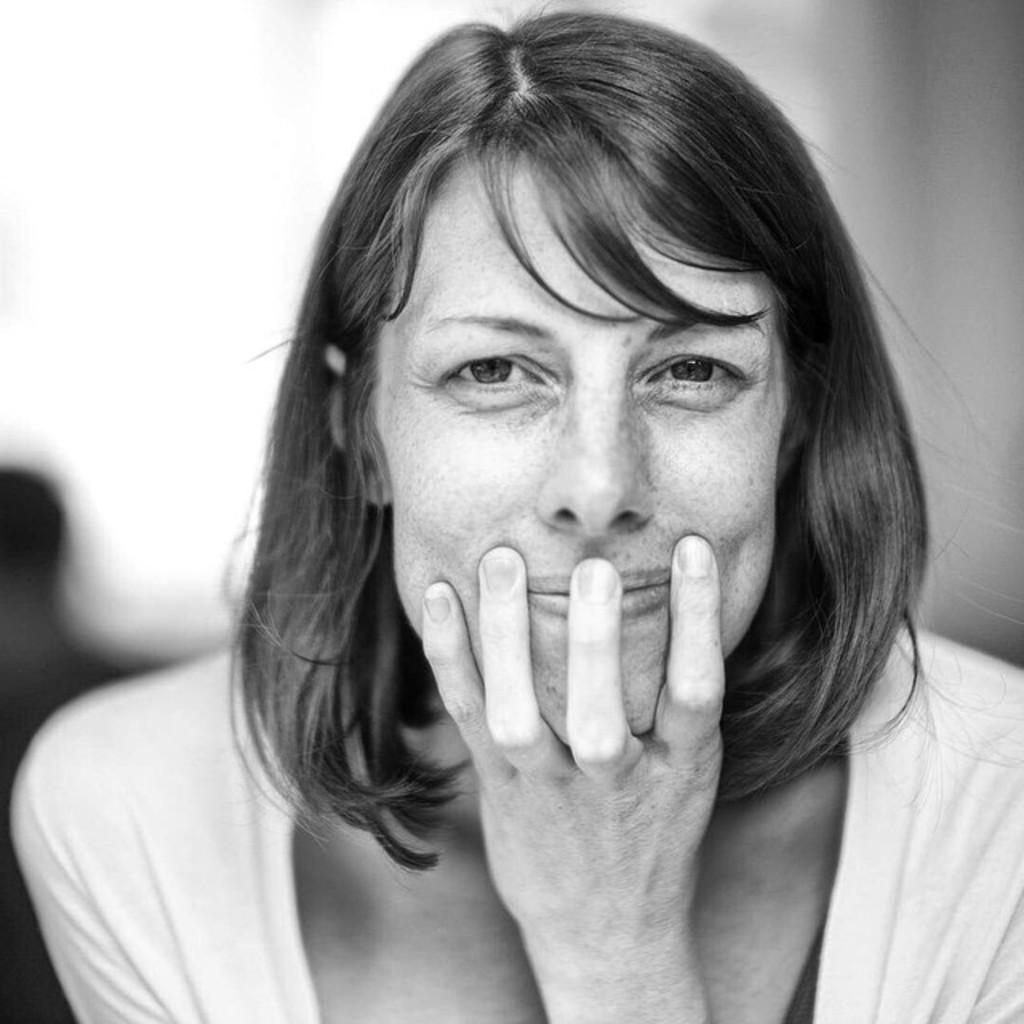What is the color scheme of the image? The image is black and white. What is the main subject of the image? There is a picture of a woman in the image. How many lizards are present in the image? There are no lizards present in the image; it features a picture of a woman in a black and white color scheme. 